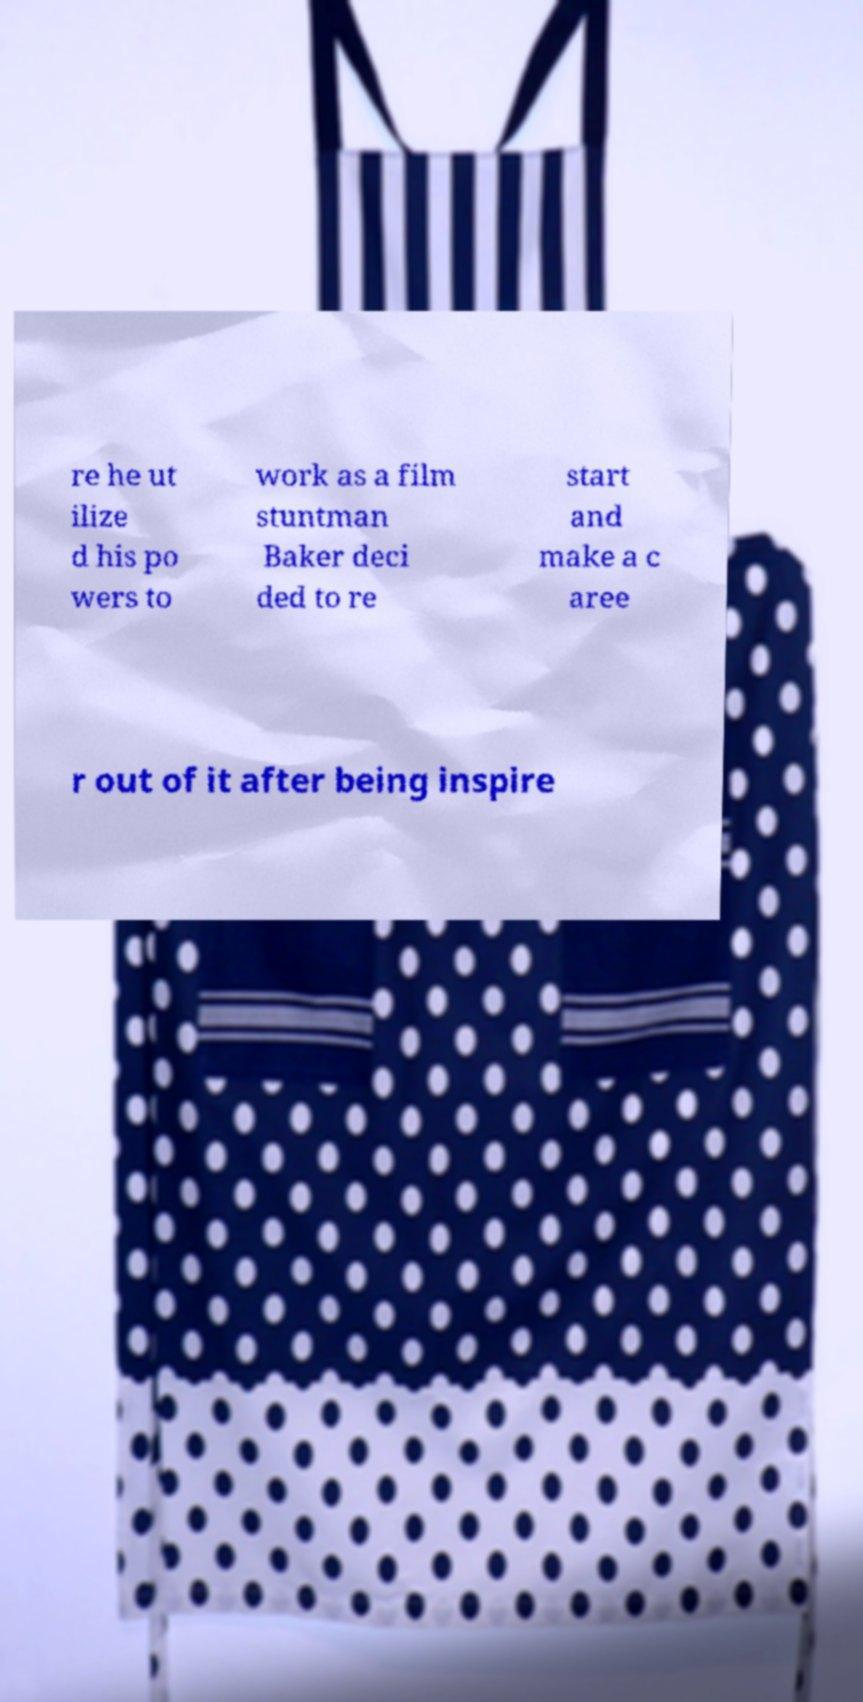For documentation purposes, I need the text within this image transcribed. Could you provide that? re he ut ilize d his po wers to work as a film stuntman Baker deci ded to re start and make a c aree r out of it after being inspire 